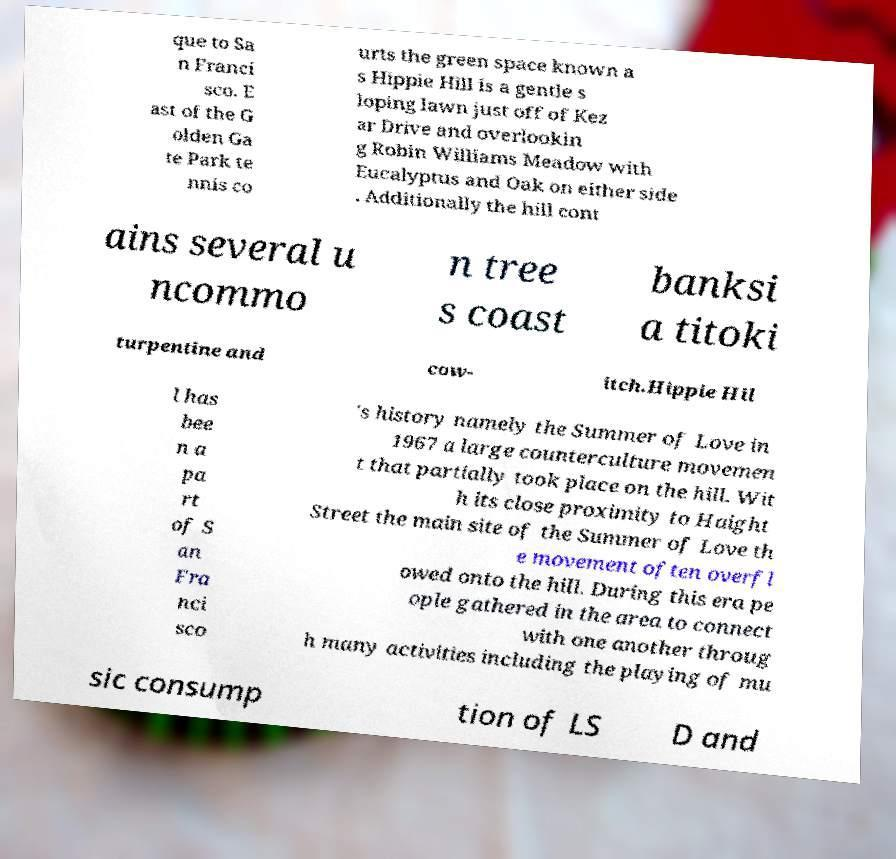I need the written content from this picture converted into text. Can you do that? que to Sa n Franci sco. E ast of the G olden Ga te Park te nnis co urts the green space known a s Hippie Hill is a gentle s loping lawn just off of Kez ar Drive and overlookin g Robin Williams Meadow with Eucalyptus and Oak on either side . Additionally the hill cont ains several u ncommo n tree s coast banksi a titoki turpentine and cow- itch.Hippie Hil l has bee n a pa rt of S an Fra nci sco 's history namely the Summer of Love in 1967 a large counterculture movemen t that partially took place on the hill. Wit h its close proximity to Haight Street the main site of the Summer of Love th e movement often overfl owed onto the hill. During this era pe ople gathered in the area to connect with one another throug h many activities including the playing of mu sic consump tion of LS D and 